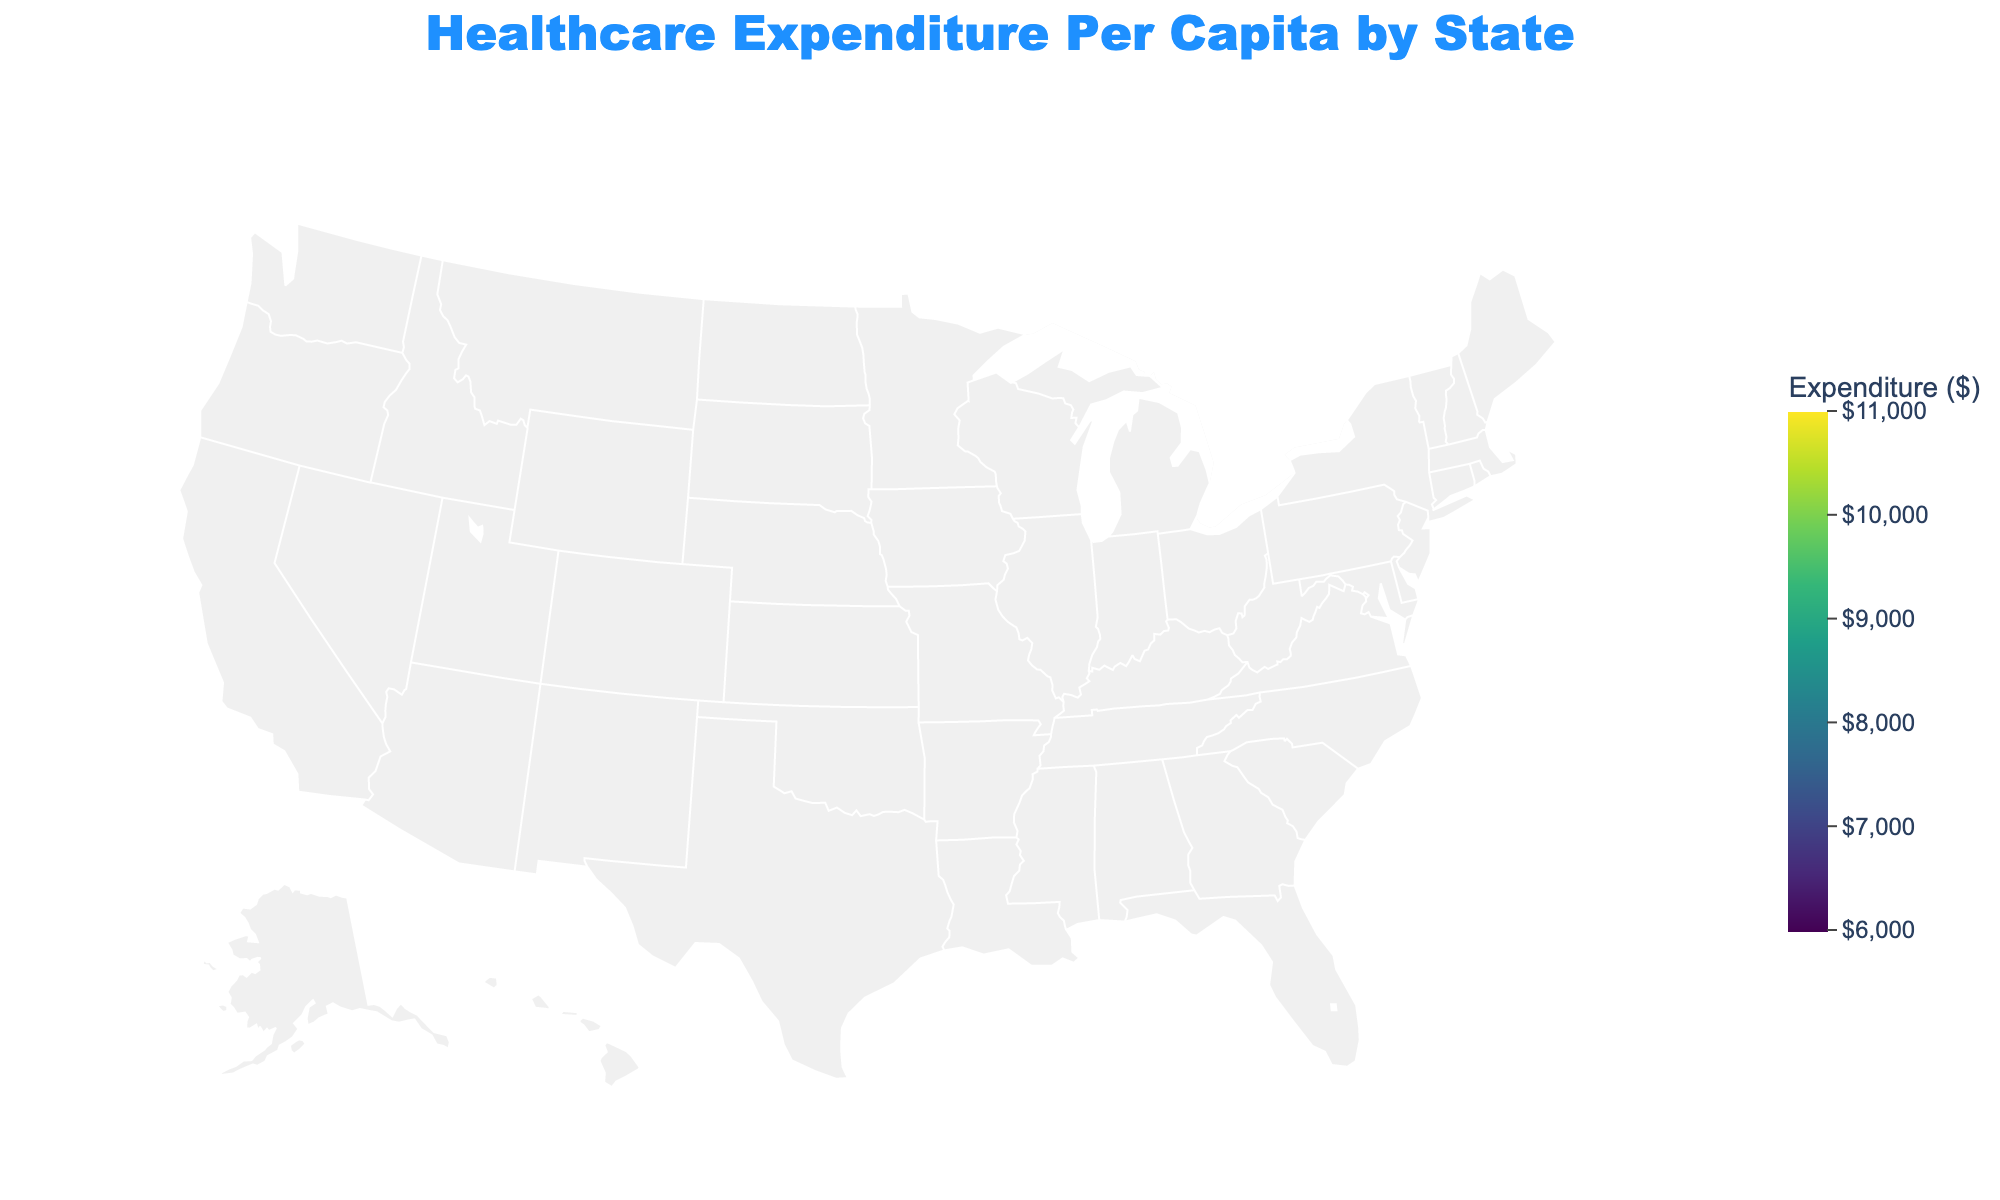What is the title of the plot? The title is positioned prominently at the top of the plot, indicating the main subject of the visual representation.
Answer: Healthcare Expenditure Per Capita by State Which state has the highest healthcare expenditure per capita? By looking at the range and color scale in the plot, the darkest color usually represents the highest values. Massachusetts has the darkest color indicating it has the highest expenditure.
Answer: Massachusetts What is the healthcare expenditure per capita in Texas? The hover feature in the plot allows us to see detailed information of each state. For Texas, it shows $6998 when hovered over.
Answer: $6998 Identify the state with the healthcare expenditure per capita of $8004. By checking the hover information and labels, both Washington and Kentucky show an expenditure per capita of $8004.
Answer: Washington and Kentucky Compare the healthcare expenditure per capita of New York and New Jersey. Which one is higher? Both states are highlighted with their respective expenditure values. Comparing the two, New Jersey shows $9859 while New York shows $9851.
Answer: New Jersey What is the average healthcare expenditure per capita for California and Florida? Sum the expenditure for California and Florida: $7549 + $8076 = $15625, then divide by 2 to get the average.
Answer: $7812.50 Which states have a healthcare expenditure per capita of less than $7000? Examining the lower end of the color scale and hovering over states provides detailed values. Georgia ($6587) and Arizona ($6452) fit this criterion.
Answer: Georgia and Arizona What is the range of healthcare expenditure per capita depicted in the plot? The plot's color scale ranges from the minimum to the maximum expenditure values across all states, shown from $6000 to $11000.
Answer: $6000 to $11000 How many states have a healthcare expenditure per capita greater than $9000? By identifying states that fall within the upper range of the color scale ($9000 – $11000) and hovering over these states gives us exact counts. Four states (New York, New Jersey, Pennsylvania, Massachusetts, Connecticut) are found.
Answer: 4 What is the total healthcare expenditure per capita for states labeled with values between $7000 and $8000? Summing up the values for states in this range: Texas ($6998), Colorado ($7076), North Carolina ($7264), Alabama ($7281), South Carolina ($7311), Kentucky ($7372), Virginia ($7423), Oklahoma ($7627), Louisiana ($7815), Missouri ($8107), Indiana ($8300).
Answer: $74174 